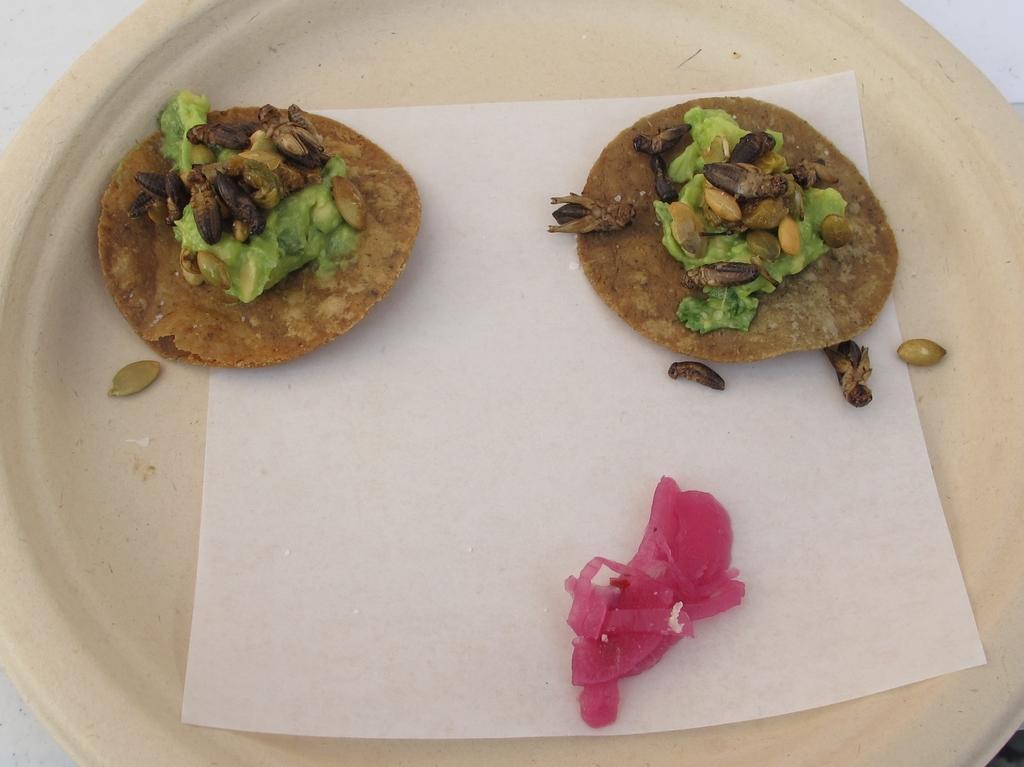Describe this image in one or two sentences. We can see plate with food and paper on white surface. 